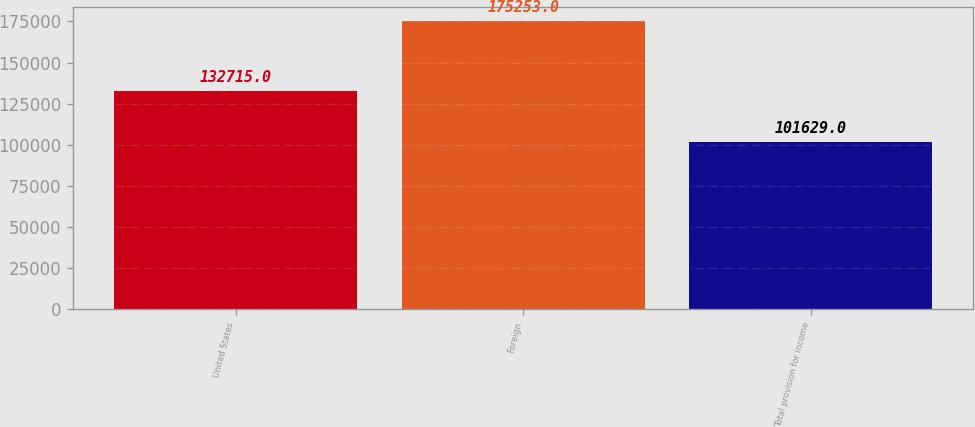Convert chart. <chart><loc_0><loc_0><loc_500><loc_500><bar_chart><fcel>United States<fcel>Foreign<fcel>Total provision for income<nl><fcel>132715<fcel>175253<fcel>101629<nl></chart> 